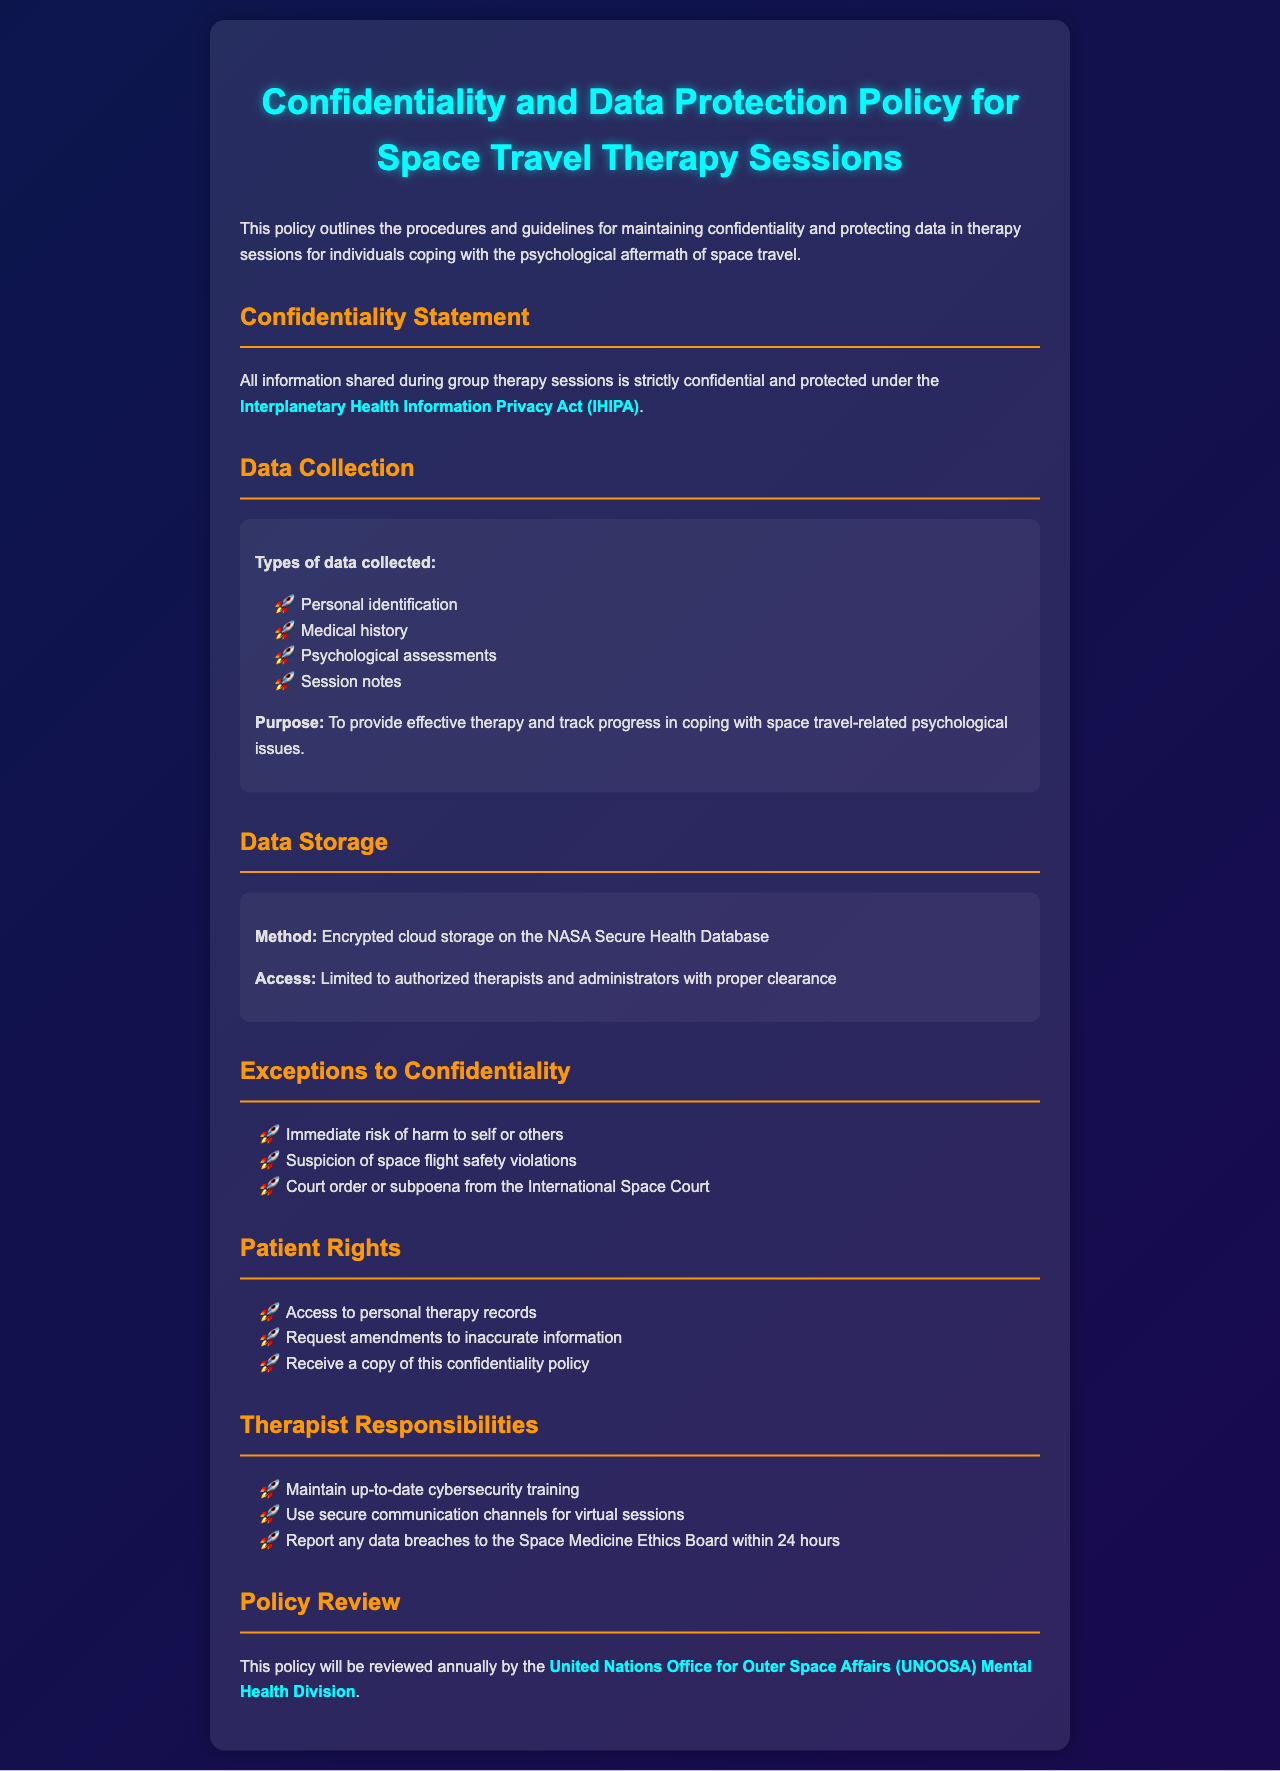what is the name of the act that protects information shared during therapy sessions? The act that protects information is mentioned specifically in the confidentiality statement section of the document.
Answer: Interplanetary Health Information Privacy Act (IHIPA) what types of data are collected during therapy sessions? The types of data are listed under the data collection section, including personal identification, medical history, etc.
Answer: Personal identification, Medical history, Psychological assessments, Session notes who has access to the stored data? The access to the stored data is specified in the data storage section, highlighting who is authorized to access it.
Answer: Authorized therapists and administrators with proper clearance what are two exceptions to confidentiality listed in the document? The exceptions are provided in a list format within the exceptions to confidentiality section.
Answer: Immediate risk of harm to self or others, Suspicion of space flight safety violations how often will the confidentiality policy be reviewed? The frequency of the policy review is specifically stated in the policy review section.
Answer: Annually what is one patient right listed in the document? The patient rights are detailed in a list; any one of those rights can be considered a correct answer.
Answer: Access to personal therapy records what responsibilities do therapists have regarding cybersecurity? The responsibilities are outlined in the therapist responsibilities section, specifying what therapists must maintain.
Answer: Maintain up-to-date cybersecurity training which organization reviews the confidentiality policy? The organization responsible for reviewing the policy is mentioned in the policy review section.
Answer: United Nations Office for Outer Space Affairs (UNOOSA) Mental Health Division 